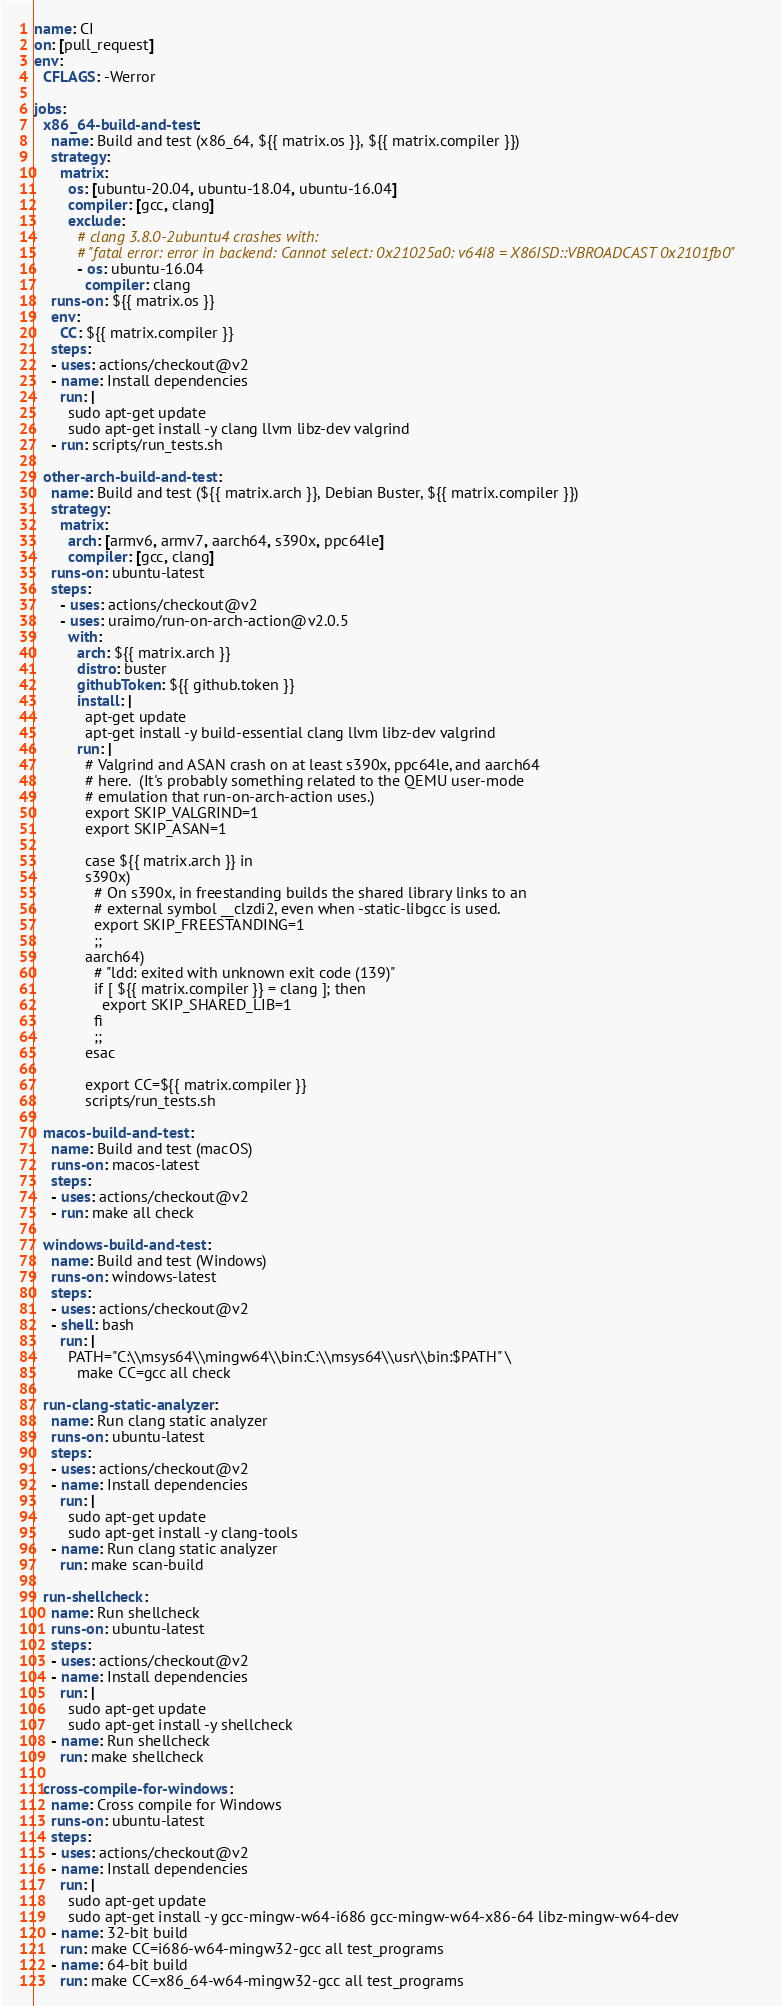Convert code to text. <code><loc_0><loc_0><loc_500><loc_500><_YAML_>name: CI
on: [pull_request]
env:
  CFLAGS: -Werror

jobs:
  x86_64-build-and-test:
    name: Build and test (x86_64, ${{ matrix.os }}, ${{ matrix.compiler }})
    strategy:
      matrix:
        os: [ubuntu-20.04, ubuntu-18.04, ubuntu-16.04]
        compiler: [gcc, clang]
        exclude:
          # clang 3.8.0-2ubuntu4 crashes with:
          # "fatal error: error in backend: Cannot select: 0x21025a0: v64i8 = X86ISD::VBROADCAST 0x2101fb0"
          - os: ubuntu-16.04
            compiler: clang
    runs-on: ${{ matrix.os }}
    env:
      CC: ${{ matrix.compiler }}
    steps:
    - uses: actions/checkout@v2
    - name: Install dependencies
      run: |
        sudo apt-get update
        sudo apt-get install -y clang llvm libz-dev valgrind
    - run: scripts/run_tests.sh

  other-arch-build-and-test:
    name: Build and test (${{ matrix.arch }}, Debian Buster, ${{ matrix.compiler }})
    strategy:
      matrix:
        arch: [armv6, armv7, aarch64, s390x, ppc64le]
        compiler: [gcc, clang]
    runs-on: ubuntu-latest
    steps:
      - uses: actions/checkout@v2
      - uses: uraimo/run-on-arch-action@v2.0.5
        with:
          arch: ${{ matrix.arch }}
          distro: buster
          githubToken: ${{ github.token }}
          install: |
            apt-get update
            apt-get install -y build-essential clang llvm libz-dev valgrind
          run: |
            # Valgrind and ASAN crash on at least s390x, ppc64le, and aarch64
            # here.  (It's probably something related to the QEMU user-mode
            # emulation that run-on-arch-action uses.)
            export SKIP_VALGRIND=1
            export SKIP_ASAN=1

            case ${{ matrix.arch }} in
            s390x)
              # On s390x, in freestanding builds the shared library links to an
              # external symbol __clzdi2, even when -static-libgcc is used.
              export SKIP_FREESTANDING=1
              ;;
            aarch64)
              # "ldd: exited with unknown exit code (139)"
              if [ ${{ matrix.compiler }} = clang ]; then
                export SKIP_SHARED_LIB=1
              fi
              ;;
            esac

            export CC=${{ matrix.compiler }}
            scripts/run_tests.sh

  macos-build-and-test:
    name: Build and test (macOS)
    runs-on: macos-latest
    steps:
    - uses: actions/checkout@v2
    - run: make all check

  windows-build-and-test:
    name: Build and test (Windows)
    runs-on: windows-latest
    steps:
    - uses: actions/checkout@v2
    - shell: bash
      run: |
        PATH="C:\\msys64\\mingw64\\bin:C:\\msys64\\usr\\bin:$PATH" \
          make CC=gcc all check

  run-clang-static-analyzer:
    name: Run clang static analyzer
    runs-on: ubuntu-latest
    steps:
    - uses: actions/checkout@v2
    - name: Install dependencies
      run: |
        sudo apt-get update
        sudo apt-get install -y clang-tools
    - name: Run clang static analyzer
      run: make scan-build

  run-shellcheck:
    name: Run shellcheck
    runs-on: ubuntu-latest
    steps:
    - uses: actions/checkout@v2
    - name: Install dependencies
      run: |
        sudo apt-get update
        sudo apt-get install -y shellcheck
    - name: Run shellcheck
      run: make shellcheck

  cross-compile-for-windows:
    name: Cross compile for Windows
    runs-on: ubuntu-latest
    steps:
    - uses: actions/checkout@v2
    - name: Install dependencies
      run: |
        sudo apt-get update
        sudo apt-get install -y gcc-mingw-w64-i686 gcc-mingw-w64-x86-64 libz-mingw-w64-dev
    - name: 32-bit build
      run: make CC=i686-w64-mingw32-gcc all test_programs
    - name: 64-bit build
      run: make CC=x86_64-w64-mingw32-gcc all test_programs
</code> 